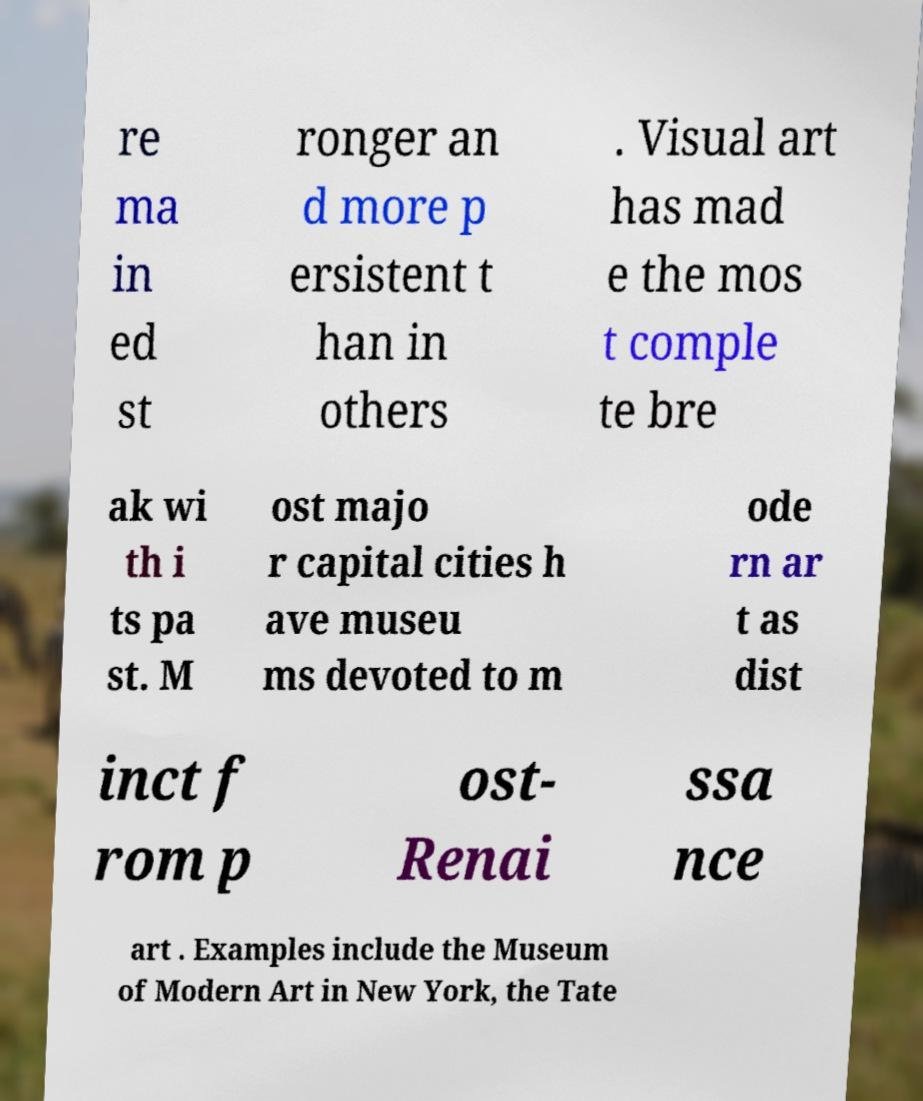What messages or text are displayed in this image? I need them in a readable, typed format. re ma in ed st ronger an d more p ersistent t han in others . Visual art has mad e the mos t comple te bre ak wi th i ts pa st. M ost majo r capital cities h ave museu ms devoted to m ode rn ar t as dist inct f rom p ost- Renai ssa nce art . Examples include the Museum of Modern Art in New York, the Tate 